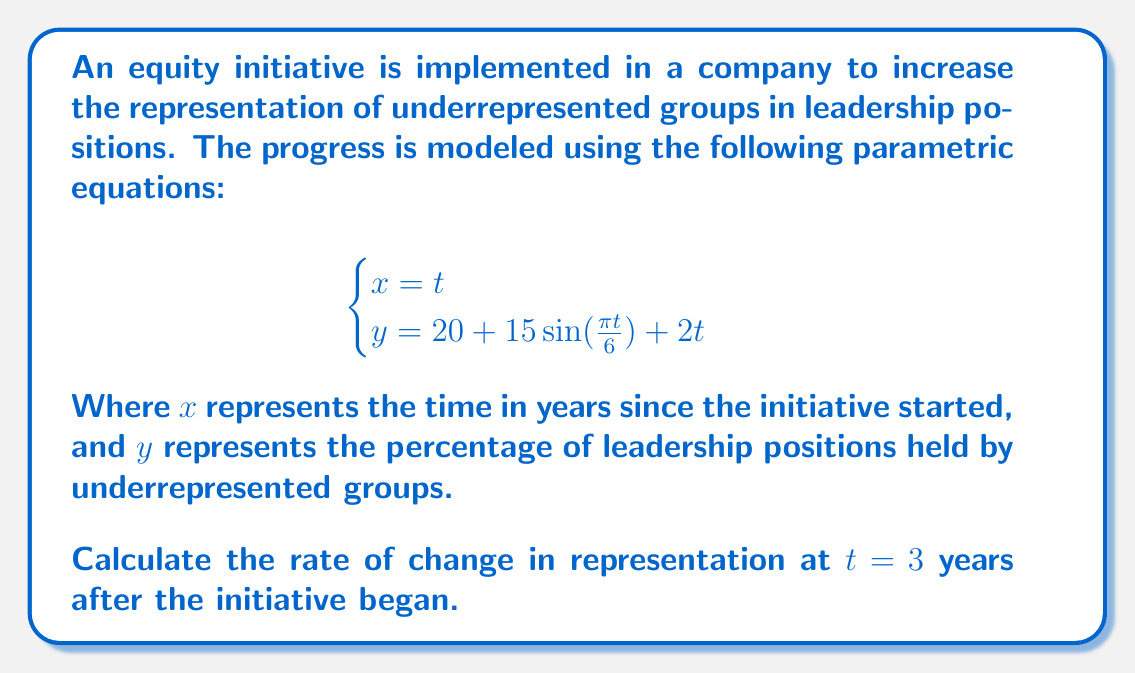Help me with this question. To find the rate of change in representation at $t = 3$ years, we need to calculate $\frac{dy}{dx}$ at $t = 3$. Since we have parametric equations, we'll use the chain rule:

$$\frac{dy}{dx} = \frac{dy/dt}{dx/dt}$$

1. First, let's find $\frac{dx}{dt}$ and $\frac{dy}{dt}$:

   $$\frac{dx}{dt} = 1$$

   $$\frac{dy}{dt} = 15 \cdot \frac{\pi}{6} \cos(\frac{\pi t}{6}) + 2$$

2. Now, we can substitute these into our formula for $\frac{dy}{dx}$:

   $$\frac{dy}{dx} = \frac{15 \cdot \frac{\pi}{6} \cos(\frac{\pi t}{6}) + 2}{1} = 15 \cdot \frac{\pi}{6} \cos(\frac{\pi t}{6}) + 2$$

3. To evaluate this at $t = 3$, we substitute $t = 3$ into our equation:

   $$\frac{dy}{dx}\bigg|_{t=3} = 15 \cdot \frac{\pi}{6} \cos(\frac{\pi \cdot 3}{6}) + 2$$

4. Simplify:
   $$\frac{dy}{dx}\bigg|_{t=3} = 15 \cdot \frac{\pi}{6} \cos(\frac{\pi}{2}) + 2$$

   $$= 15 \cdot \frac{\pi}{6} \cdot 0 + 2$$

   $$= 2$$

Therefore, the rate of change in representation at $t = 3$ years after the initiative began is 2 percentage points per year.
Answer: 2 percentage points per year 